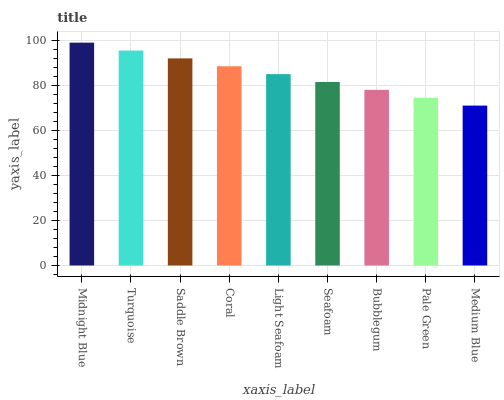Is Turquoise the minimum?
Answer yes or no. No. Is Turquoise the maximum?
Answer yes or no. No. Is Midnight Blue greater than Turquoise?
Answer yes or no. Yes. Is Turquoise less than Midnight Blue?
Answer yes or no. Yes. Is Turquoise greater than Midnight Blue?
Answer yes or no. No. Is Midnight Blue less than Turquoise?
Answer yes or no. No. Is Light Seafoam the high median?
Answer yes or no. Yes. Is Light Seafoam the low median?
Answer yes or no. Yes. Is Coral the high median?
Answer yes or no. No. Is Saddle Brown the low median?
Answer yes or no. No. 